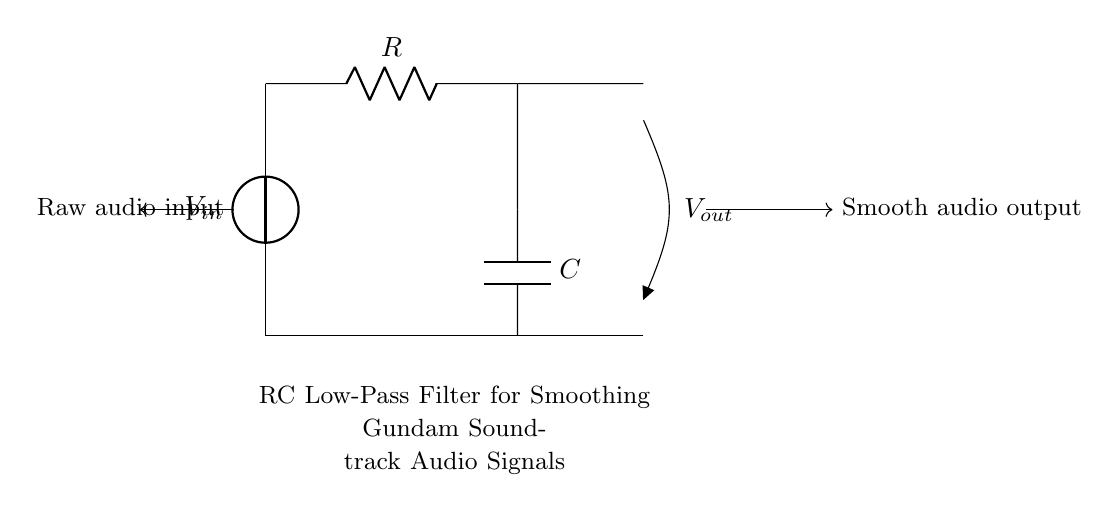What type of circuit is represented? The circuit diagram shows a low-pass filter, specifically an RC (resistor-capacitor) circuit used to smooth audio signals. The resistor and capacitor work together to allow low-frequency signals to pass while attenuating higher frequencies.
Answer: RC low-pass filter What are the components in this circuit? The circuit consists of two main components: a resistor, labeled R, and a capacitor, labeled C. These components are connected in a specific arrangement that defines their function as a filter.
Answer: Resistor and Capacitor What is the role of the capacitor in this circuit? The capacitor in this RC low-pass filter serves to store and release electrical energy, which helps to smooth out fluctuations in the audio signal. It works by charging and discharging according to the frequency of the incoming signal, thus changing the output voltage over time.
Answer: Smoothing audio signals What happens to high-frequency signals in this circuit? High-frequency signals are attenuated when they pass through the RC low-pass filter. This means that the circuit reduces the amplitude of these signals, preventing them from appearing in the output, which is crucial for cleaning up audio signals where only lower frequencies are desired.
Answer: Attenuated What is the output voltage when the input voltage is at a low frequency? At low frequencies, the output voltage approaches the input voltage, as the capacitor charges up and allows the low-frequency signals to pass through effectively. This is important for preserving the integrity of the audio signal in the desired frequency range.
Answer: Approximately equal to input voltage How does the value of the resistor affect the cutoff frequency? The cutoff frequency of the low-pass filter is determined by both the resistor and the capacitor values. The formula for cutoff frequency is f_c = 1/(2πRC), meaning that increasing the resistance will lower the cutoff frequency, allowing fewer high frequencies to pass through.
Answer: Decrease cutoff frequency What is represented by Vout in the circuit? Vout represents the output voltage across the capacitor, which is the smoothed audio signal that has passed through the RC low-pass filter. It is typically lower in frequency and free of high-frequency noise compared to the raw input.
Answer: Smoothed audio output 